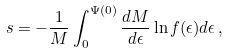<formula> <loc_0><loc_0><loc_500><loc_500>s = - \frac { 1 } { M } \int ^ { \Psi ( 0 ) } _ { 0 } \frac { d M } { d \epsilon } \ln f ( \epsilon ) d \epsilon \, ,</formula> 